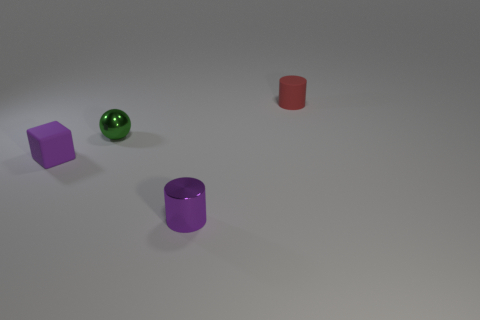Subtract 1 cubes. How many cubes are left? 0 Add 2 green shiny balls. How many objects exist? 6 Subtract all blue cylinders. Subtract all cyan blocks. How many cylinders are left? 2 Subtract all green balls. How many brown cubes are left? 0 Subtract all large metallic balls. Subtract all green metal spheres. How many objects are left? 3 Add 4 purple things. How many purple things are left? 6 Add 3 small purple metal objects. How many small purple metal objects exist? 4 Subtract 0 yellow blocks. How many objects are left? 4 Subtract all cubes. How many objects are left? 3 